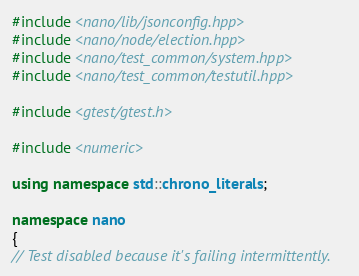Convert code to text. <code><loc_0><loc_0><loc_500><loc_500><_C++_>#include <nano/lib/jsonconfig.hpp>
#include <nano/node/election.hpp>
#include <nano/test_common/system.hpp>
#include <nano/test_common/testutil.hpp>

#include <gtest/gtest.h>

#include <numeric>

using namespace std::chrono_literals;

namespace nano
{
// Test disabled because it's failing intermittently.</code> 